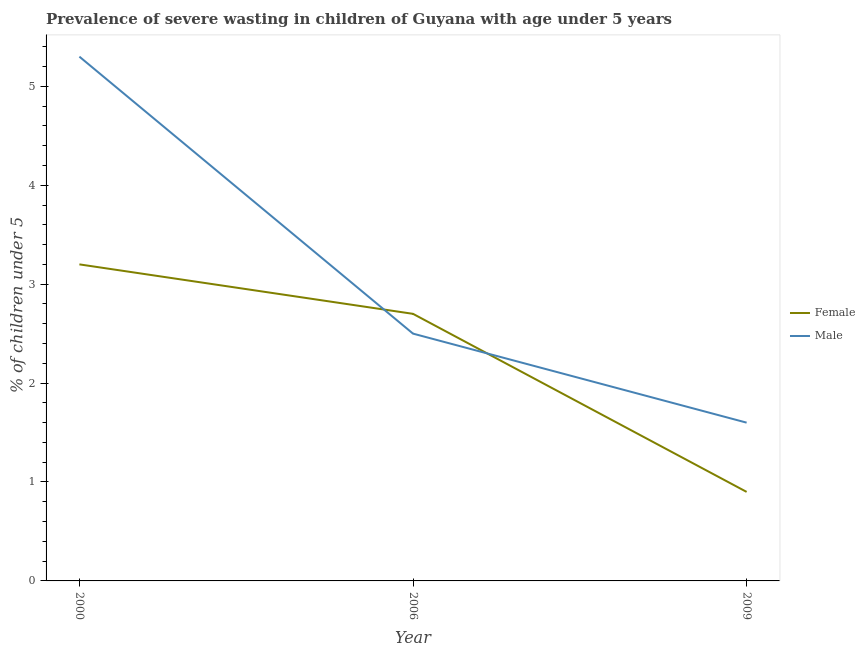How many different coloured lines are there?
Your response must be concise. 2. Is the number of lines equal to the number of legend labels?
Offer a very short reply. Yes. What is the percentage of undernourished female children in 2006?
Ensure brevity in your answer.  2.7. Across all years, what is the maximum percentage of undernourished female children?
Your answer should be compact. 3.2. Across all years, what is the minimum percentage of undernourished male children?
Give a very brief answer. 1.6. In which year was the percentage of undernourished male children maximum?
Give a very brief answer. 2000. In which year was the percentage of undernourished male children minimum?
Make the answer very short. 2009. What is the total percentage of undernourished female children in the graph?
Provide a succinct answer. 6.8. What is the difference between the percentage of undernourished female children in 2000 and that in 2009?
Keep it short and to the point. 2.3. What is the difference between the percentage of undernourished female children in 2009 and the percentage of undernourished male children in 2000?
Your response must be concise. -4.4. What is the average percentage of undernourished female children per year?
Ensure brevity in your answer.  2.27. In the year 2006, what is the difference between the percentage of undernourished female children and percentage of undernourished male children?
Your answer should be very brief. 0.2. What is the ratio of the percentage of undernourished male children in 2000 to that in 2009?
Offer a terse response. 3.31. What is the difference between the highest and the second highest percentage of undernourished male children?
Provide a short and direct response. 2.8. What is the difference between the highest and the lowest percentage of undernourished female children?
Provide a succinct answer. 2.3. In how many years, is the percentage of undernourished male children greater than the average percentage of undernourished male children taken over all years?
Keep it short and to the point. 1. Does the percentage of undernourished male children monotonically increase over the years?
Your response must be concise. No. Is the percentage of undernourished male children strictly greater than the percentage of undernourished female children over the years?
Your answer should be compact. No. How many years are there in the graph?
Keep it short and to the point. 3. Are the values on the major ticks of Y-axis written in scientific E-notation?
Your response must be concise. No. Does the graph contain any zero values?
Provide a short and direct response. No. Does the graph contain grids?
Your response must be concise. No. Where does the legend appear in the graph?
Your answer should be very brief. Center right. How many legend labels are there?
Keep it short and to the point. 2. How are the legend labels stacked?
Provide a succinct answer. Vertical. What is the title of the graph?
Keep it short and to the point. Prevalence of severe wasting in children of Guyana with age under 5 years. What is the label or title of the X-axis?
Your answer should be very brief. Year. What is the label or title of the Y-axis?
Your answer should be very brief.  % of children under 5. What is the  % of children under 5 of Female in 2000?
Offer a very short reply. 3.2. What is the  % of children under 5 of Male in 2000?
Give a very brief answer. 5.3. What is the  % of children under 5 of Female in 2006?
Your answer should be compact. 2.7. What is the  % of children under 5 of Female in 2009?
Your response must be concise. 0.9. What is the  % of children under 5 of Male in 2009?
Offer a very short reply. 1.6. Across all years, what is the maximum  % of children under 5 in Female?
Your response must be concise. 3.2. Across all years, what is the maximum  % of children under 5 of Male?
Offer a very short reply. 5.3. Across all years, what is the minimum  % of children under 5 of Female?
Give a very brief answer. 0.9. Across all years, what is the minimum  % of children under 5 in Male?
Offer a terse response. 1.6. What is the difference between the  % of children under 5 of Female in 2006 and that in 2009?
Your response must be concise. 1.8. What is the difference between the  % of children under 5 of Female in 2000 and the  % of children under 5 of Male in 2006?
Your answer should be compact. 0.7. What is the difference between the  % of children under 5 of Female in 2000 and the  % of children under 5 of Male in 2009?
Offer a terse response. 1.6. What is the difference between the  % of children under 5 in Female in 2006 and the  % of children under 5 in Male in 2009?
Give a very brief answer. 1.1. What is the average  % of children under 5 of Female per year?
Give a very brief answer. 2.27. What is the average  % of children under 5 in Male per year?
Keep it short and to the point. 3.13. In the year 2009, what is the difference between the  % of children under 5 in Female and  % of children under 5 in Male?
Provide a succinct answer. -0.7. What is the ratio of the  % of children under 5 in Female in 2000 to that in 2006?
Provide a short and direct response. 1.19. What is the ratio of the  % of children under 5 of Male in 2000 to that in 2006?
Offer a very short reply. 2.12. What is the ratio of the  % of children under 5 of Female in 2000 to that in 2009?
Your answer should be compact. 3.56. What is the ratio of the  % of children under 5 in Male in 2000 to that in 2009?
Give a very brief answer. 3.31. What is the ratio of the  % of children under 5 of Female in 2006 to that in 2009?
Offer a very short reply. 3. What is the ratio of the  % of children under 5 of Male in 2006 to that in 2009?
Your answer should be compact. 1.56. What is the difference between the highest and the second highest  % of children under 5 in Male?
Ensure brevity in your answer.  2.8. 